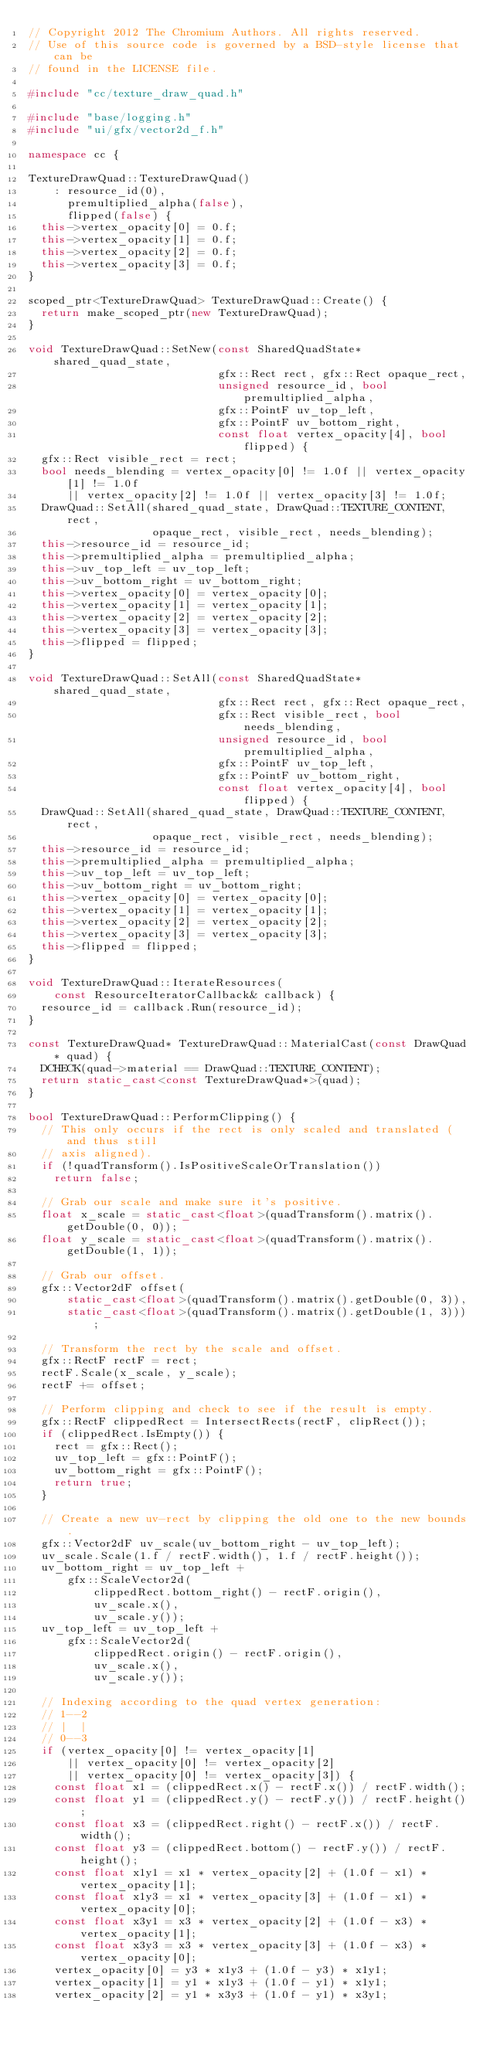<code> <loc_0><loc_0><loc_500><loc_500><_C++_>// Copyright 2012 The Chromium Authors. All rights reserved.
// Use of this source code is governed by a BSD-style license that can be
// found in the LICENSE file.

#include "cc/texture_draw_quad.h"

#include "base/logging.h"
#include "ui/gfx/vector2d_f.h"

namespace cc {

TextureDrawQuad::TextureDrawQuad()
    : resource_id(0),
      premultiplied_alpha(false),
      flipped(false) {
  this->vertex_opacity[0] = 0.f;
  this->vertex_opacity[1] = 0.f;
  this->vertex_opacity[2] = 0.f;
  this->vertex_opacity[3] = 0.f;
}

scoped_ptr<TextureDrawQuad> TextureDrawQuad::Create() {
  return make_scoped_ptr(new TextureDrawQuad);
}

void TextureDrawQuad::SetNew(const SharedQuadState* shared_quad_state,
                             gfx::Rect rect, gfx::Rect opaque_rect,
                             unsigned resource_id, bool premultiplied_alpha,
                             gfx::PointF uv_top_left,
                             gfx::PointF uv_bottom_right,
                             const float vertex_opacity[4], bool flipped) {
  gfx::Rect visible_rect = rect;
  bool needs_blending = vertex_opacity[0] != 1.0f || vertex_opacity[1] != 1.0f
      || vertex_opacity[2] != 1.0f || vertex_opacity[3] != 1.0f;
  DrawQuad::SetAll(shared_quad_state, DrawQuad::TEXTURE_CONTENT, rect,
                   opaque_rect, visible_rect, needs_blending);
  this->resource_id = resource_id;
  this->premultiplied_alpha = premultiplied_alpha;
  this->uv_top_left = uv_top_left;
  this->uv_bottom_right = uv_bottom_right;
  this->vertex_opacity[0] = vertex_opacity[0];
  this->vertex_opacity[1] = vertex_opacity[1];
  this->vertex_opacity[2] = vertex_opacity[2];
  this->vertex_opacity[3] = vertex_opacity[3];
  this->flipped = flipped;
}

void TextureDrawQuad::SetAll(const SharedQuadState* shared_quad_state,
                             gfx::Rect rect, gfx::Rect opaque_rect,
                             gfx::Rect visible_rect, bool needs_blending,
                             unsigned resource_id, bool premultiplied_alpha,
                             gfx::PointF uv_top_left,
                             gfx::PointF uv_bottom_right,
                             const float vertex_opacity[4], bool flipped) {
  DrawQuad::SetAll(shared_quad_state, DrawQuad::TEXTURE_CONTENT, rect,
                   opaque_rect, visible_rect, needs_blending);
  this->resource_id = resource_id;
  this->premultiplied_alpha = premultiplied_alpha;
  this->uv_top_left = uv_top_left;
  this->uv_bottom_right = uv_bottom_right;
  this->vertex_opacity[0] = vertex_opacity[0];
  this->vertex_opacity[1] = vertex_opacity[1];
  this->vertex_opacity[2] = vertex_opacity[2];
  this->vertex_opacity[3] = vertex_opacity[3];
  this->flipped = flipped;
}

void TextureDrawQuad::IterateResources(
    const ResourceIteratorCallback& callback) {
  resource_id = callback.Run(resource_id);
}

const TextureDrawQuad* TextureDrawQuad::MaterialCast(const DrawQuad* quad) {
  DCHECK(quad->material == DrawQuad::TEXTURE_CONTENT);
  return static_cast<const TextureDrawQuad*>(quad);
}

bool TextureDrawQuad::PerformClipping() {
  // This only occurs if the rect is only scaled and translated (and thus still
  // axis aligned).
  if (!quadTransform().IsPositiveScaleOrTranslation())
    return false;

  // Grab our scale and make sure it's positive.
  float x_scale = static_cast<float>(quadTransform().matrix().getDouble(0, 0));
  float y_scale = static_cast<float>(quadTransform().matrix().getDouble(1, 1));

  // Grab our offset.
  gfx::Vector2dF offset(
      static_cast<float>(quadTransform().matrix().getDouble(0, 3)),
      static_cast<float>(quadTransform().matrix().getDouble(1, 3)));

  // Transform the rect by the scale and offset.
  gfx::RectF rectF = rect;
  rectF.Scale(x_scale, y_scale);
  rectF += offset;

  // Perform clipping and check to see if the result is empty.
  gfx::RectF clippedRect = IntersectRects(rectF, clipRect());
  if (clippedRect.IsEmpty()) {
    rect = gfx::Rect();
    uv_top_left = gfx::PointF();
    uv_bottom_right = gfx::PointF();
    return true;
  }

  // Create a new uv-rect by clipping the old one to the new bounds.
  gfx::Vector2dF uv_scale(uv_bottom_right - uv_top_left);
  uv_scale.Scale(1.f / rectF.width(), 1.f / rectF.height());
  uv_bottom_right = uv_top_left +
      gfx::ScaleVector2d(
          clippedRect.bottom_right() - rectF.origin(),
          uv_scale.x(),
          uv_scale.y());
  uv_top_left = uv_top_left +
      gfx::ScaleVector2d(
          clippedRect.origin() - rectF.origin(),
          uv_scale.x(),
          uv_scale.y());

  // Indexing according to the quad vertex generation:
  // 1--2
  // |  |
  // 0--3
  if (vertex_opacity[0] != vertex_opacity[1]
      || vertex_opacity[0] != vertex_opacity[2]
      || vertex_opacity[0] != vertex_opacity[3]) {
    const float x1 = (clippedRect.x() - rectF.x()) / rectF.width();
    const float y1 = (clippedRect.y() - rectF.y()) / rectF.height();
    const float x3 = (clippedRect.right() - rectF.x()) / rectF.width();
    const float y3 = (clippedRect.bottom() - rectF.y()) / rectF.height();
    const float x1y1 = x1 * vertex_opacity[2] + (1.0f - x1) * vertex_opacity[1];
    const float x1y3 = x1 * vertex_opacity[3] + (1.0f - x1) * vertex_opacity[0];
    const float x3y1 = x3 * vertex_opacity[2] + (1.0f - x3) * vertex_opacity[1];
    const float x3y3 = x3 * vertex_opacity[3] + (1.0f - x3) * vertex_opacity[0];
    vertex_opacity[0] = y3 * x1y3 + (1.0f - y3) * x1y1;
    vertex_opacity[1] = y1 * x1y3 + (1.0f - y1) * x1y1;
    vertex_opacity[2] = y1 * x3y3 + (1.0f - y1) * x3y1;</code> 